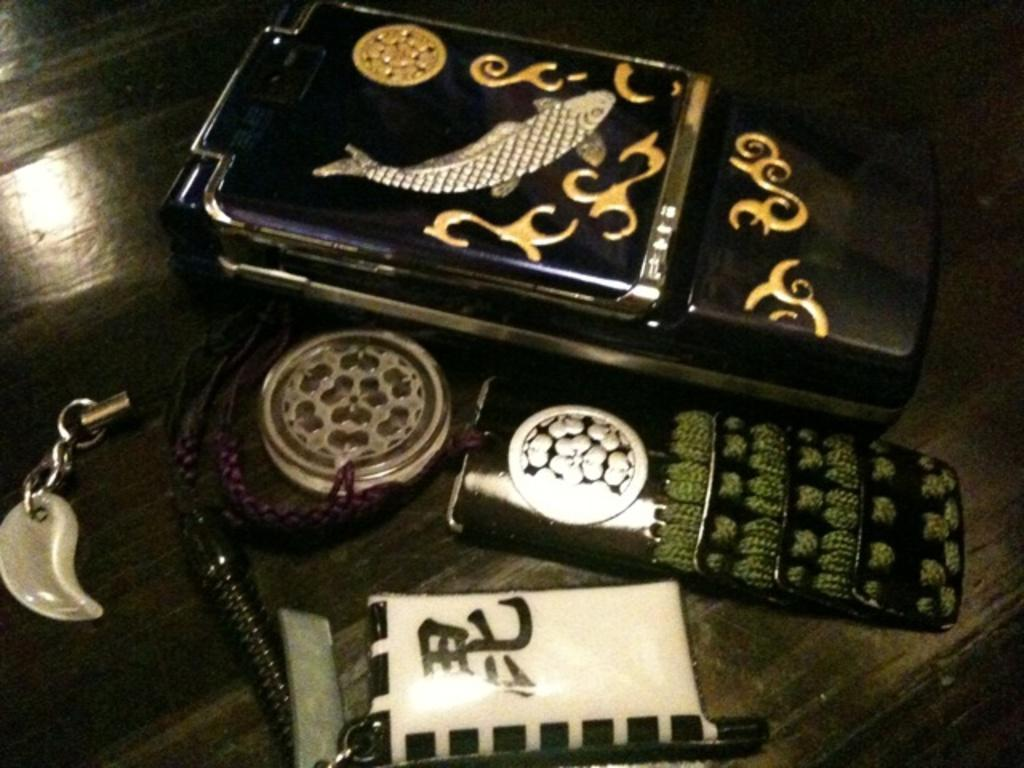What type of objects can be seen in the image? There are mobiles and a keychain in the image. Where are the objects located? The objects are on a table. What is the color of the table? The table is brown in color. What is the caption for the image? There is no caption present in the image. What type of breakfast is being served on the table in the image? There is no breakfast present in the image; it only features mobiles and a keychain on a table. 